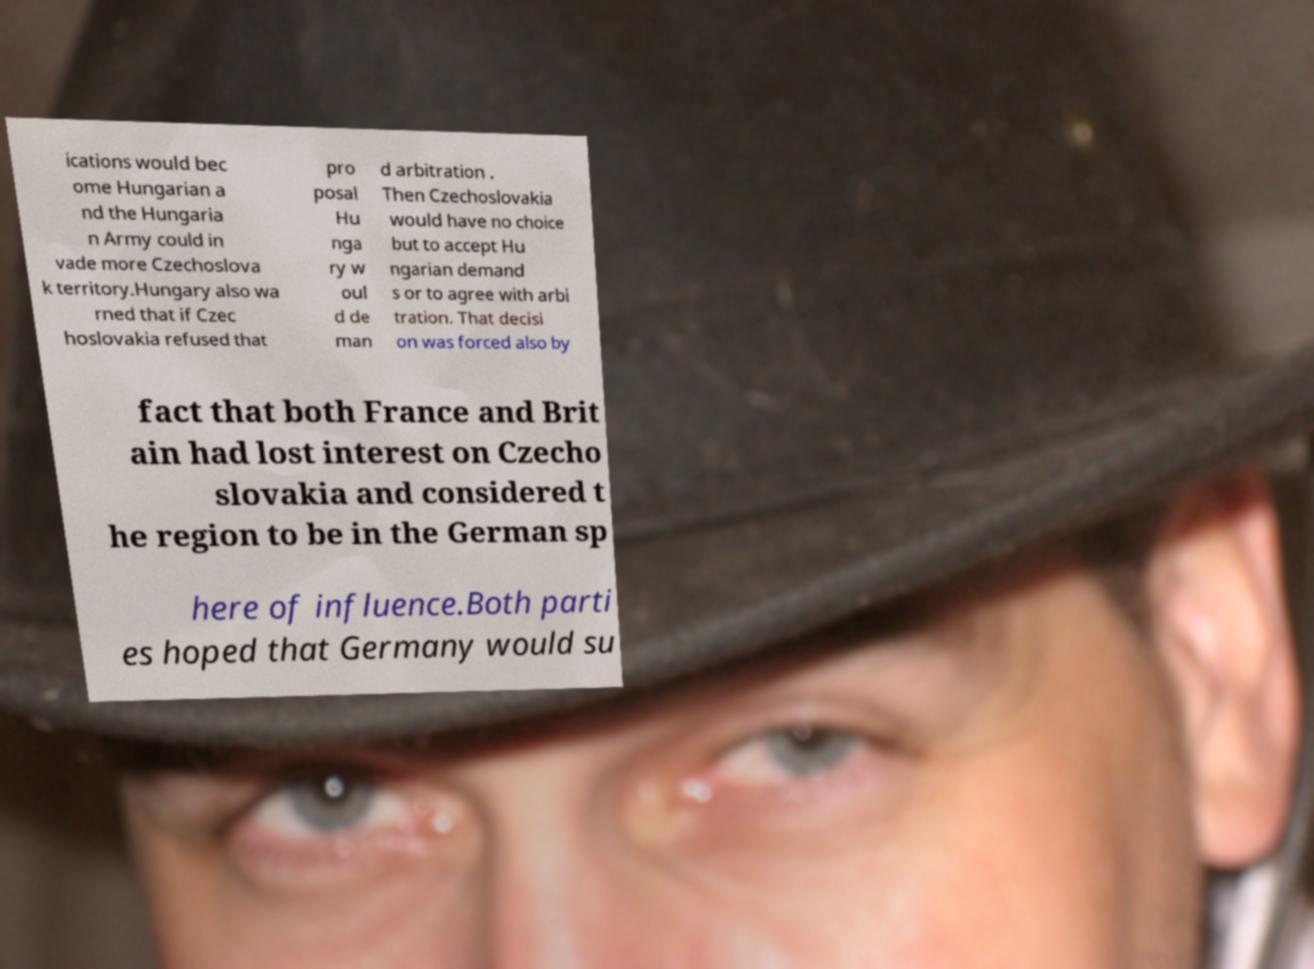Please identify and transcribe the text found in this image. ications would bec ome Hungarian a nd the Hungaria n Army could in vade more Czechoslova k territory.Hungary also wa rned that if Czec hoslovakia refused that pro posal Hu nga ry w oul d de man d arbitration . Then Czechoslovakia would have no choice but to accept Hu ngarian demand s or to agree with arbi tration. That decisi on was forced also by fact that both France and Brit ain had lost interest on Czecho slovakia and considered t he region to be in the German sp here of influence.Both parti es hoped that Germany would su 